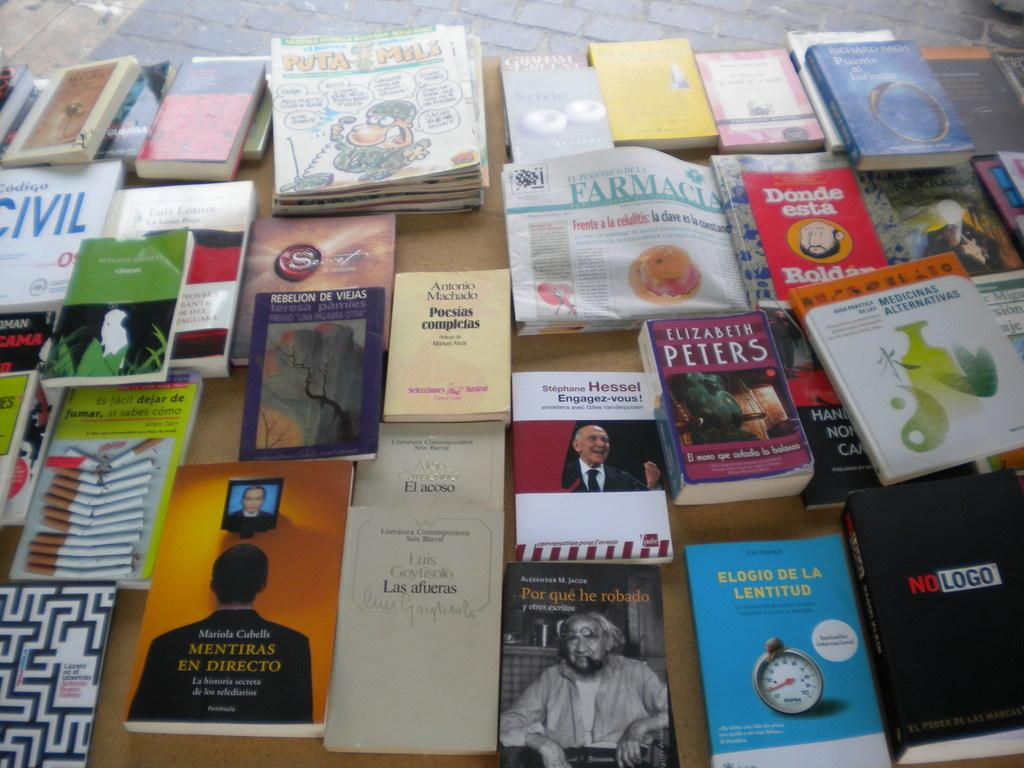<image>
Share a concise interpretation of the image provided. A lot of books from various artists including Elizabeth Peters 